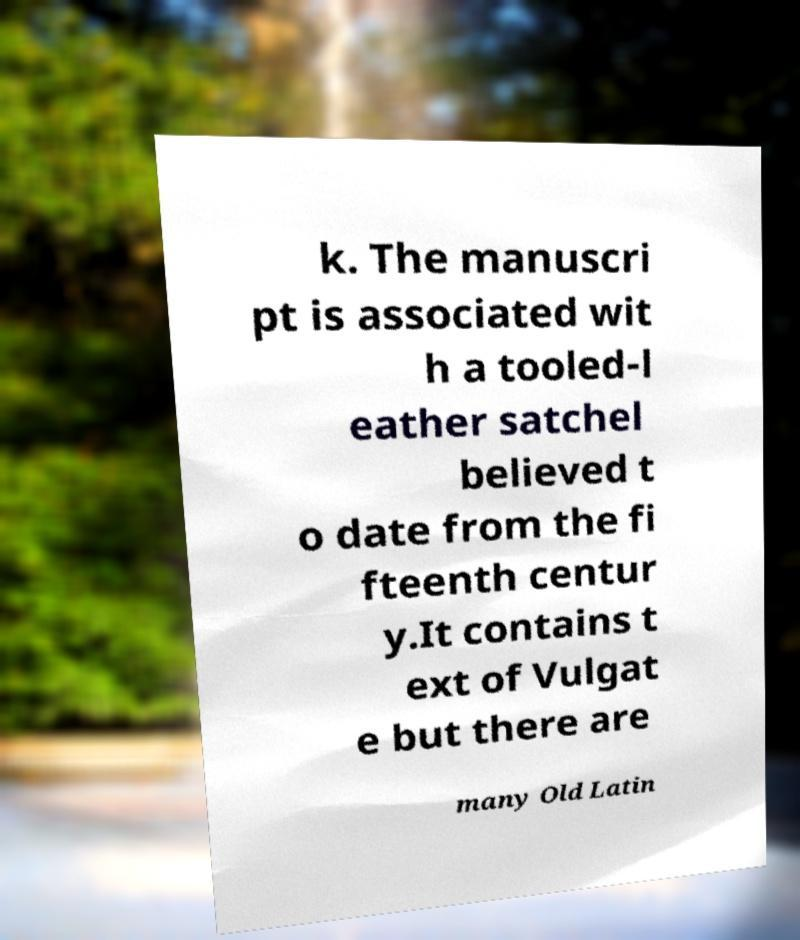Please read and relay the text visible in this image. What does it say? k. The manuscri pt is associated wit h a tooled-l eather satchel believed t o date from the fi fteenth centur y.It contains t ext of Vulgat e but there are many Old Latin 